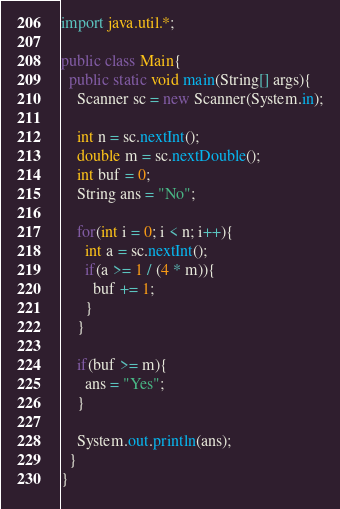<code> <loc_0><loc_0><loc_500><loc_500><_Java_>import java.util.*;

public class Main{
  public static void main(String[] args){
    Scanner sc = new Scanner(System.in);

    int n = sc.nextInt();
    double m = sc.nextDouble();
    int buf = 0;
    String ans = "No";

    for(int i = 0; i < n; i++){
      int a = sc.nextInt();
      if(a >= 1 / (4 * m)){
        buf += 1;
      }
    }

    if(buf >= m){
      ans = "Yes";
    }

    System.out.println(ans);
  }
}
</code> 